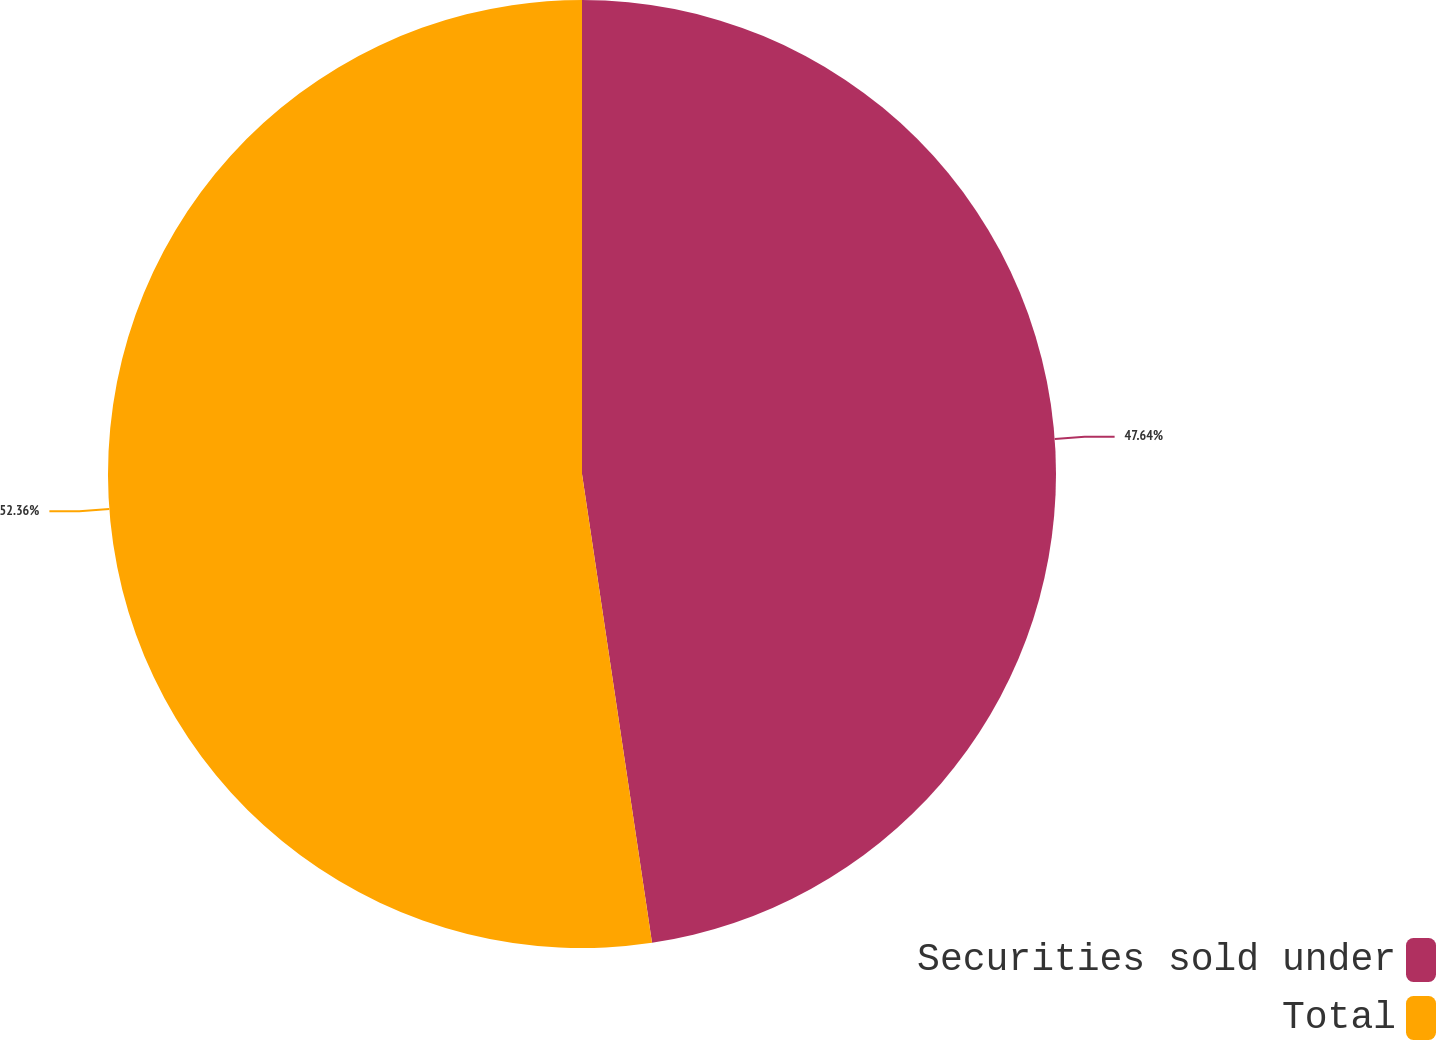Convert chart to OTSL. <chart><loc_0><loc_0><loc_500><loc_500><pie_chart><fcel>Securities sold under<fcel>Total<nl><fcel>47.64%<fcel>52.36%<nl></chart> 